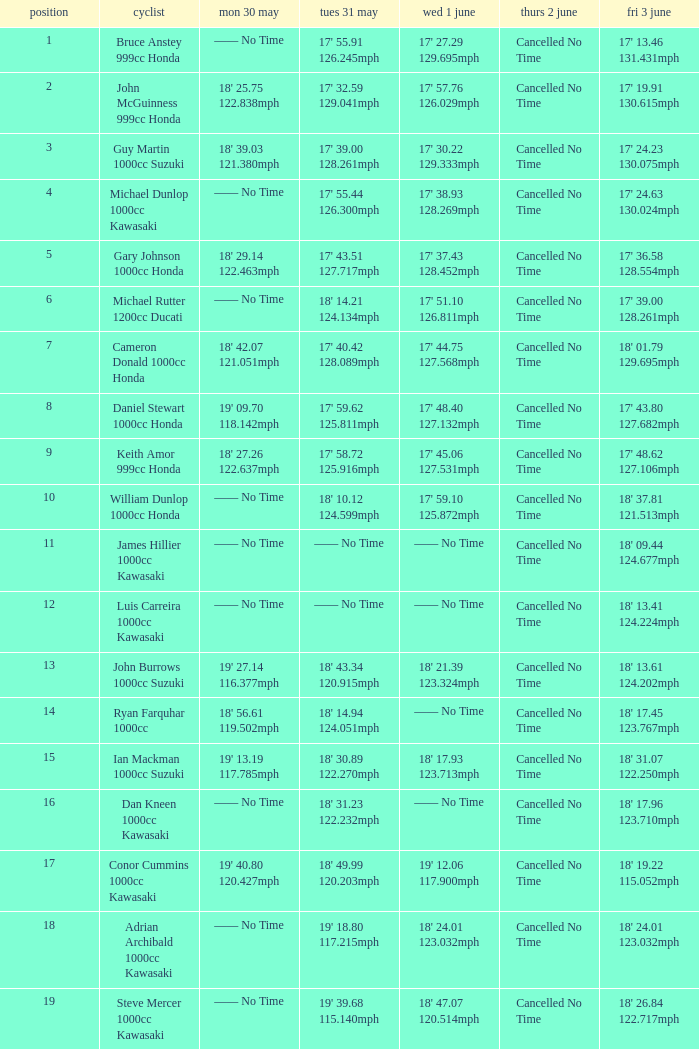What is the Thurs 2 June time for the rider with a Fri 3 June time of 17' 36.58 128.554mph? Cancelled No Time. 